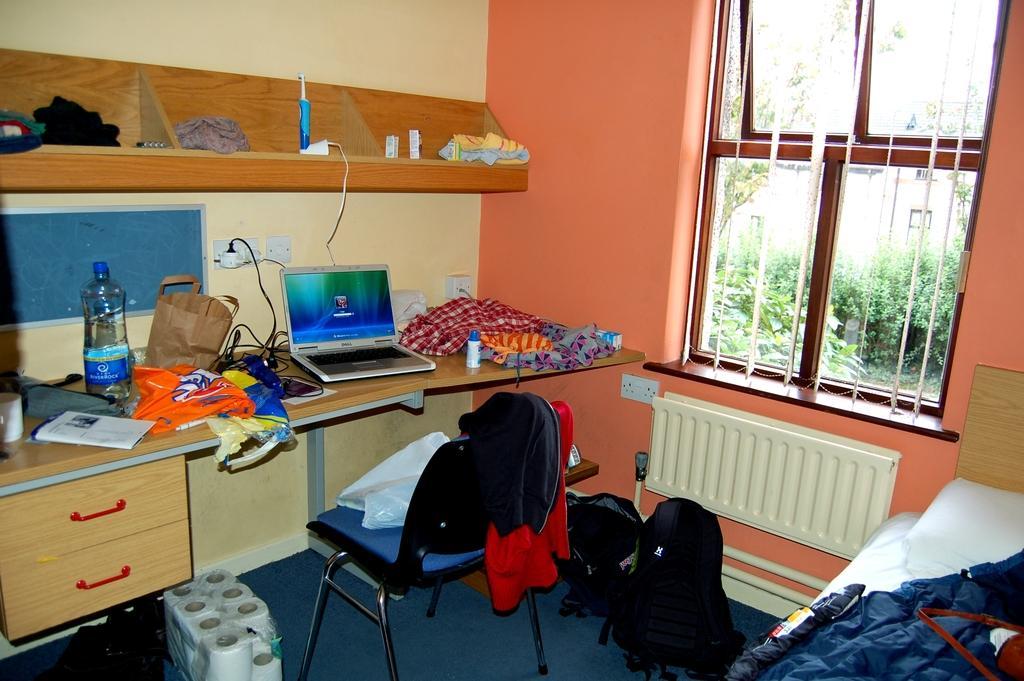Can you describe this image briefly? This is a desk. laptop,water bottle,bag,clothes and some other objects are placed on the desk. This is a chair with some clothes on it. I can see some tissue paper rolls placed on the floor. At the right corner of the image I can see a bed with blanket on it. And this is a window with grills and doors. I can trees through the window. This is a wall and this is a socket where cables are connected. 